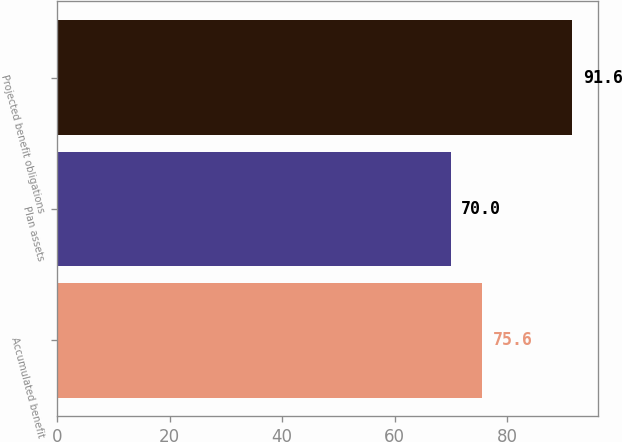Convert chart. <chart><loc_0><loc_0><loc_500><loc_500><bar_chart><fcel>Accumulated benefit<fcel>Plan assets<fcel>Projected benefit obligations<nl><fcel>75.6<fcel>70<fcel>91.6<nl></chart> 